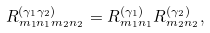<formula> <loc_0><loc_0><loc_500><loc_500>R ^ { ( \gamma _ { 1 } \gamma _ { 2 } ) } _ { m _ { 1 } n _ { 1 } m _ { 2 } n _ { 2 } } = R ^ { ( \gamma _ { 1 } ) } _ { m _ { 1 } n _ { 1 } } R ^ { ( \gamma _ { 2 } ) } _ { m _ { 2 } n _ { 2 } } ,</formula> 